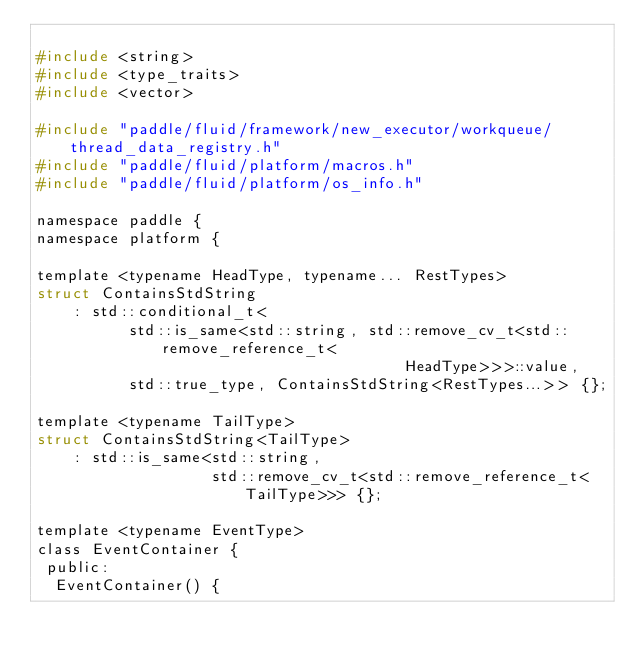<code> <loc_0><loc_0><loc_500><loc_500><_C_>
#include <string>
#include <type_traits>
#include <vector>

#include "paddle/fluid/framework/new_executor/workqueue/thread_data_registry.h"
#include "paddle/fluid/platform/macros.h"
#include "paddle/fluid/platform/os_info.h"

namespace paddle {
namespace platform {

template <typename HeadType, typename... RestTypes>
struct ContainsStdString
    : std::conditional_t<
          std::is_same<std::string, std::remove_cv_t<std::remove_reference_t<
                                        HeadType>>>::value,
          std::true_type, ContainsStdString<RestTypes...>> {};

template <typename TailType>
struct ContainsStdString<TailType>
    : std::is_same<std::string,
                   std::remove_cv_t<std::remove_reference_t<TailType>>> {};

template <typename EventType>
class EventContainer {
 public:
  EventContainer() {</code> 